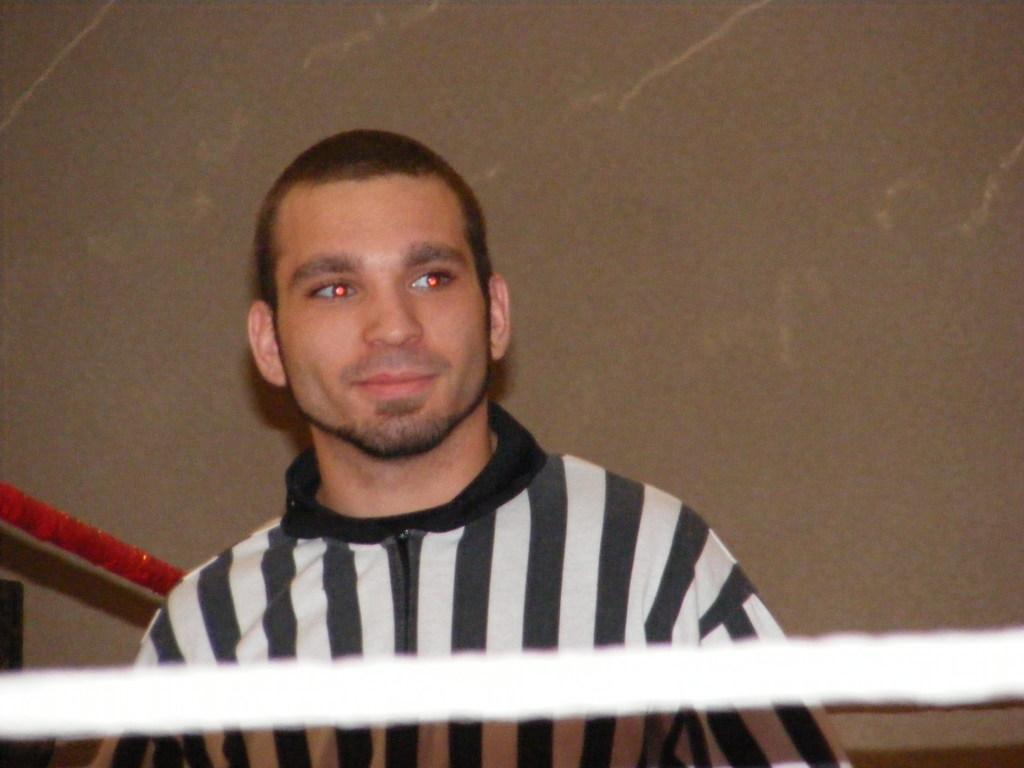In one or two sentences, can you explain what this image depicts? In the picture we can see a man wearing a T-shirt on it, we can see black and white color lines and in front of him we can see a white color rope and behind him we can see a red color rope and a wall. 